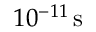Convert formula to latex. <formula><loc_0><loc_0><loc_500><loc_500>1 0 ^ { - 1 1 } \, s</formula> 